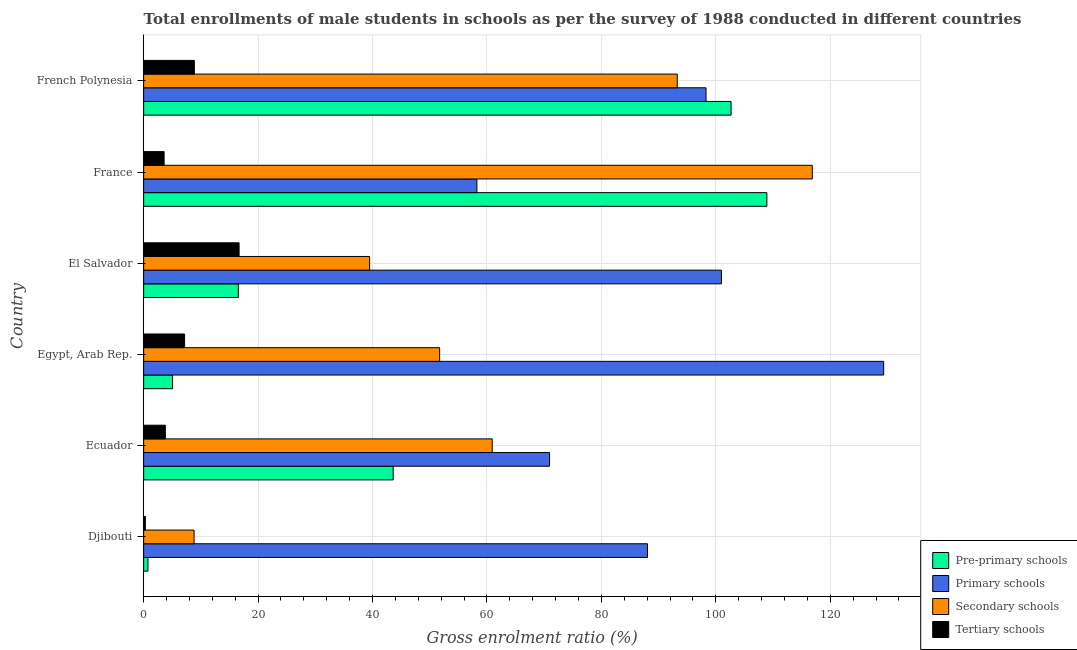Are the number of bars on each tick of the Y-axis equal?
Ensure brevity in your answer.  Yes. How many bars are there on the 3rd tick from the top?
Your answer should be compact. 4. How many bars are there on the 3rd tick from the bottom?
Your answer should be very brief. 4. What is the label of the 6th group of bars from the top?
Provide a short and direct response. Djibouti. What is the gross enrolment ratio(male) in pre-primary schools in Ecuador?
Make the answer very short. 43.61. Across all countries, what is the maximum gross enrolment ratio(male) in pre-primary schools?
Your answer should be compact. 108.92. Across all countries, what is the minimum gross enrolment ratio(male) in primary schools?
Provide a short and direct response. 58.24. In which country was the gross enrolment ratio(male) in tertiary schools minimum?
Provide a succinct answer. Djibouti. What is the total gross enrolment ratio(male) in secondary schools in the graph?
Your answer should be compact. 371.08. What is the difference between the gross enrolment ratio(male) in secondary schools in Djibouti and that in French Polynesia?
Provide a succinct answer. -84.45. What is the difference between the gross enrolment ratio(male) in secondary schools in Ecuador and the gross enrolment ratio(male) in pre-primary schools in Djibouti?
Your answer should be compact. 60.17. What is the average gross enrolment ratio(male) in tertiary schools per country?
Provide a succinct answer. 6.73. What is the difference between the gross enrolment ratio(male) in secondary schools and gross enrolment ratio(male) in primary schools in French Polynesia?
Make the answer very short. -5.03. In how many countries, is the gross enrolment ratio(male) in secondary schools greater than 40 %?
Your answer should be very brief. 4. What is the ratio of the gross enrolment ratio(male) in pre-primary schools in Djibouti to that in France?
Provide a succinct answer. 0.01. Is the gross enrolment ratio(male) in secondary schools in Egypt, Arab Rep. less than that in El Salvador?
Make the answer very short. No. Is the difference between the gross enrolment ratio(male) in pre-primary schools in Djibouti and Egypt, Arab Rep. greater than the difference between the gross enrolment ratio(male) in secondary schools in Djibouti and Egypt, Arab Rep.?
Provide a short and direct response. Yes. What is the difference between the highest and the second highest gross enrolment ratio(male) in primary schools?
Make the answer very short. 28.36. What is the difference between the highest and the lowest gross enrolment ratio(male) in tertiary schools?
Keep it short and to the point. 16.38. In how many countries, is the gross enrolment ratio(male) in primary schools greater than the average gross enrolment ratio(male) in primary schools taken over all countries?
Keep it short and to the point. 3. Is the sum of the gross enrolment ratio(male) in pre-primary schools in France and French Polynesia greater than the maximum gross enrolment ratio(male) in secondary schools across all countries?
Keep it short and to the point. Yes. What does the 3rd bar from the top in France represents?
Offer a very short reply. Primary schools. What does the 1st bar from the bottom in Djibouti represents?
Ensure brevity in your answer.  Pre-primary schools. Are the values on the major ticks of X-axis written in scientific E-notation?
Ensure brevity in your answer.  No. Does the graph contain any zero values?
Keep it short and to the point. No. How many legend labels are there?
Offer a very short reply. 4. How are the legend labels stacked?
Your answer should be compact. Vertical. What is the title of the graph?
Provide a succinct answer. Total enrollments of male students in schools as per the survey of 1988 conducted in different countries. What is the label or title of the X-axis?
Ensure brevity in your answer.  Gross enrolment ratio (%). What is the label or title of the Y-axis?
Your response must be concise. Country. What is the Gross enrolment ratio (%) of Pre-primary schools in Djibouti?
Your answer should be very brief. 0.75. What is the Gross enrolment ratio (%) of Primary schools in Djibouti?
Your answer should be compact. 88.05. What is the Gross enrolment ratio (%) in Secondary schools in Djibouti?
Provide a short and direct response. 8.81. What is the Gross enrolment ratio (%) in Tertiary schools in Djibouti?
Your response must be concise. 0.3. What is the Gross enrolment ratio (%) in Pre-primary schools in Ecuador?
Your response must be concise. 43.61. What is the Gross enrolment ratio (%) of Primary schools in Ecuador?
Your answer should be compact. 70.94. What is the Gross enrolment ratio (%) in Secondary schools in Ecuador?
Provide a succinct answer. 60.92. What is the Gross enrolment ratio (%) of Tertiary schools in Ecuador?
Give a very brief answer. 3.79. What is the Gross enrolment ratio (%) of Pre-primary schools in Egypt, Arab Rep.?
Provide a succinct answer. 5.05. What is the Gross enrolment ratio (%) in Primary schools in Egypt, Arab Rep.?
Your answer should be very brief. 129.34. What is the Gross enrolment ratio (%) of Secondary schools in Egypt, Arab Rep.?
Offer a terse response. 51.73. What is the Gross enrolment ratio (%) in Tertiary schools in Egypt, Arab Rep.?
Provide a succinct answer. 7.16. What is the Gross enrolment ratio (%) of Pre-primary schools in El Salvador?
Keep it short and to the point. 16.54. What is the Gross enrolment ratio (%) of Primary schools in El Salvador?
Offer a very short reply. 100.98. What is the Gross enrolment ratio (%) in Secondary schools in El Salvador?
Provide a succinct answer. 39.5. What is the Gross enrolment ratio (%) in Tertiary schools in El Salvador?
Provide a succinct answer. 16.68. What is the Gross enrolment ratio (%) of Pre-primary schools in France?
Offer a terse response. 108.92. What is the Gross enrolment ratio (%) of Primary schools in France?
Your answer should be compact. 58.24. What is the Gross enrolment ratio (%) of Secondary schools in France?
Make the answer very short. 116.86. What is the Gross enrolment ratio (%) in Tertiary schools in France?
Provide a succinct answer. 3.58. What is the Gross enrolment ratio (%) in Pre-primary schools in French Polynesia?
Give a very brief answer. 102.67. What is the Gross enrolment ratio (%) in Primary schools in French Polynesia?
Ensure brevity in your answer.  98.29. What is the Gross enrolment ratio (%) in Secondary schools in French Polynesia?
Your answer should be compact. 93.26. What is the Gross enrolment ratio (%) of Tertiary schools in French Polynesia?
Ensure brevity in your answer.  8.86. Across all countries, what is the maximum Gross enrolment ratio (%) in Pre-primary schools?
Your response must be concise. 108.92. Across all countries, what is the maximum Gross enrolment ratio (%) of Primary schools?
Your response must be concise. 129.34. Across all countries, what is the maximum Gross enrolment ratio (%) of Secondary schools?
Provide a short and direct response. 116.86. Across all countries, what is the maximum Gross enrolment ratio (%) in Tertiary schools?
Offer a very short reply. 16.68. Across all countries, what is the minimum Gross enrolment ratio (%) of Pre-primary schools?
Ensure brevity in your answer.  0.75. Across all countries, what is the minimum Gross enrolment ratio (%) in Primary schools?
Your answer should be compact. 58.24. Across all countries, what is the minimum Gross enrolment ratio (%) of Secondary schools?
Give a very brief answer. 8.81. Across all countries, what is the minimum Gross enrolment ratio (%) in Tertiary schools?
Your answer should be very brief. 0.3. What is the total Gross enrolment ratio (%) in Pre-primary schools in the graph?
Keep it short and to the point. 277.55. What is the total Gross enrolment ratio (%) of Primary schools in the graph?
Give a very brief answer. 545.85. What is the total Gross enrolment ratio (%) in Secondary schools in the graph?
Ensure brevity in your answer.  371.08. What is the total Gross enrolment ratio (%) in Tertiary schools in the graph?
Ensure brevity in your answer.  40.37. What is the difference between the Gross enrolment ratio (%) in Pre-primary schools in Djibouti and that in Ecuador?
Offer a very short reply. -42.86. What is the difference between the Gross enrolment ratio (%) of Primary schools in Djibouti and that in Ecuador?
Offer a terse response. 17.11. What is the difference between the Gross enrolment ratio (%) in Secondary schools in Djibouti and that in Ecuador?
Your response must be concise. -52.11. What is the difference between the Gross enrolment ratio (%) of Tertiary schools in Djibouti and that in Ecuador?
Offer a very short reply. -3.49. What is the difference between the Gross enrolment ratio (%) of Pre-primary schools in Djibouti and that in Egypt, Arab Rep.?
Offer a very short reply. -4.29. What is the difference between the Gross enrolment ratio (%) of Primary schools in Djibouti and that in Egypt, Arab Rep.?
Give a very brief answer. -41.29. What is the difference between the Gross enrolment ratio (%) of Secondary schools in Djibouti and that in Egypt, Arab Rep.?
Your answer should be very brief. -42.92. What is the difference between the Gross enrolment ratio (%) in Tertiary schools in Djibouti and that in Egypt, Arab Rep.?
Provide a succinct answer. -6.86. What is the difference between the Gross enrolment ratio (%) in Pre-primary schools in Djibouti and that in El Salvador?
Offer a very short reply. -15.79. What is the difference between the Gross enrolment ratio (%) of Primary schools in Djibouti and that in El Salvador?
Ensure brevity in your answer.  -12.93. What is the difference between the Gross enrolment ratio (%) in Secondary schools in Djibouti and that in El Salvador?
Provide a short and direct response. -30.68. What is the difference between the Gross enrolment ratio (%) of Tertiary schools in Djibouti and that in El Salvador?
Offer a very short reply. -16.38. What is the difference between the Gross enrolment ratio (%) of Pre-primary schools in Djibouti and that in France?
Your response must be concise. -108.17. What is the difference between the Gross enrolment ratio (%) of Primary schools in Djibouti and that in France?
Make the answer very short. 29.81. What is the difference between the Gross enrolment ratio (%) of Secondary schools in Djibouti and that in France?
Your answer should be compact. -108.05. What is the difference between the Gross enrolment ratio (%) in Tertiary schools in Djibouti and that in France?
Your answer should be very brief. -3.28. What is the difference between the Gross enrolment ratio (%) in Pre-primary schools in Djibouti and that in French Polynesia?
Provide a short and direct response. -101.92. What is the difference between the Gross enrolment ratio (%) in Primary schools in Djibouti and that in French Polynesia?
Your answer should be very brief. -10.24. What is the difference between the Gross enrolment ratio (%) of Secondary schools in Djibouti and that in French Polynesia?
Give a very brief answer. -84.45. What is the difference between the Gross enrolment ratio (%) of Tertiary schools in Djibouti and that in French Polynesia?
Your response must be concise. -8.56. What is the difference between the Gross enrolment ratio (%) of Pre-primary schools in Ecuador and that in Egypt, Arab Rep.?
Your answer should be very brief. 38.56. What is the difference between the Gross enrolment ratio (%) in Primary schools in Ecuador and that in Egypt, Arab Rep.?
Give a very brief answer. -58.4. What is the difference between the Gross enrolment ratio (%) of Secondary schools in Ecuador and that in Egypt, Arab Rep.?
Offer a very short reply. 9.19. What is the difference between the Gross enrolment ratio (%) in Tertiary schools in Ecuador and that in Egypt, Arab Rep.?
Give a very brief answer. -3.37. What is the difference between the Gross enrolment ratio (%) in Pre-primary schools in Ecuador and that in El Salvador?
Your answer should be compact. 27.07. What is the difference between the Gross enrolment ratio (%) of Primary schools in Ecuador and that in El Salvador?
Give a very brief answer. -30.04. What is the difference between the Gross enrolment ratio (%) of Secondary schools in Ecuador and that in El Salvador?
Make the answer very short. 21.43. What is the difference between the Gross enrolment ratio (%) of Tertiary schools in Ecuador and that in El Salvador?
Provide a short and direct response. -12.89. What is the difference between the Gross enrolment ratio (%) of Pre-primary schools in Ecuador and that in France?
Keep it short and to the point. -65.31. What is the difference between the Gross enrolment ratio (%) in Primary schools in Ecuador and that in France?
Ensure brevity in your answer.  12.7. What is the difference between the Gross enrolment ratio (%) of Secondary schools in Ecuador and that in France?
Give a very brief answer. -55.94. What is the difference between the Gross enrolment ratio (%) of Tertiary schools in Ecuador and that in France?
Your answer should be very brief. 0.21. What is the difference between the Gross enrolment ratio (%) in Pre-primary schools in Ecuador and that in French Polynesia?
Make the answer very short. -59.06. What is the difference between the Gross enrolment ratio (%) in Primary schools in Ecuador and that in French Polynesia?
Provide a succinct answer. -27.35. What is the difference between the Gross enrolment ratio (%) in Secondary schools in Ecuador and that in French Polynesia?
Provide a short and direct response. -32.34. What is the difference between the Gross enrolment ratio (%) of Tertiary schools in Ecuador and that in French Polynesia?
Keep it short and to the point. -5.07. What is the difference between the Gross enrolment ratio (%) of Pre-primary schools in Egypt, Arab Rep. and that in El Salvador?
Offer a terse response. -11.5. What is the difference between the Gross enrolment ratio (%) of Primary schools in Egypt, Arab Rep. and that in El Salvador?
Your response must be concise. 28.36. What is the difference between the Gross enrolment ratio (%) of Secondary schools in Egypt, Arab Rep. and that in El Salvador?
Provide a short and direct response. 12.24. What is the difference between the Gross enrolment ratio (%) in Tertiary schools in Egypt, Arab Rep. and that in El Salvador?
Keep it short and to the point. -9.52. What is the difference between the Gross enrolment ratio (%) of Pre-primary schools in Egypt, Arab Rep. and that in France?
Your response must be concise. -103.87. What is the difference between the Gross enrolment ratio (%) of Primary schools in Egypt, Arab Rep. and that in France?
Your answer should be compact. 71.1. What is the difference between the Gross enrolment ratio (%) of Secondary schools in Egypt, Arab Rep. and that in France?
Provide a short and direct response. -65.13. What is the difference between the Gross enrolment ratio (%) of Tertiary schools in Egypt, Arab Rep. and that in France?
Make the answer very short. 3.58. What is the difference between the Gross enrolment ratio (%) of Pre-primary schools in Egypt, Arab Rep. and that in French Polynesia?
Offer a very short reply. -97.62. What is the difference between the Gross enrolment ratio (%) of Primary schools in Egypt, Arab Rep. and that in French Polynesia?
Provide a short and direct response. 31.05. What is the difference between the Gross enrolment ratio (%) in Secondary schools in Egypt, Arab Rep. and that in French Polynesia?
Your answer should be compact. -41.53. What is the difference between the Gross enrolment ratio (%) in Tertiary schools in Egypt, Arab Rep. and that in French Polynesia?
Your response must be concise. -1.71. What is the difference between the Gross enrolment ratio (%) of Pre-primary schools in El Salvador and that in France?
Your answer should be compact. -92.38. What is the difference between the Gross enrolment ratio (%) of Primary schools in El Salvador and that in France?
Make the answer very short. 42.74. What is the difference between the Gross enrolment ratio (%) in Secondary schools in El Salvador and that in France?
Provide a succinct answer. -77.37. What is the difference between the Gross enrolment ratio (%) of Tertiary schools in El Salvador and that in France?
Keep it short and to the point. 13.1. What is the difference between the Gross enrolment ratio (%) in Pre-primary schools in El Salvador and that in French Polynesia?
Your response must be concise. -86.13. What is the difference between the Gross enrolment ratio (%) in Primary schools in El Salvador and that in French Polynesia?
Give a very brief answer. 2.69. What is the difference between the Gross enrolment ratio (%) of Secondary schools in El Salvador and that in French Polynesia?
Your answer should be very brief. -53.77. What is the difference between the Gross enrolment ratio (%) of Tertiary schools in El Salvador and that in French Polynesia?
Ensure brevity in your answer.  7.82. What is the difference between the Gross enrolment ratio (%) in Pre-primary schools in France and that in French Polynesia?
Your response must be concise. 6.25. What is the difference between the Gross enrolment ratio (%) of Primary schools in France and that in French Polynesia?
Give a very brief answer. -40.05. What is the difference between the Gross enrolment ratio (%) in Secondary schools in France and that in French Polynesia?
Your answer should be compact. 23.6. What is the difference between the Gross enrolment ratio (%) of Tertiary schools in France and that in French Polynesia?
Make the answer very short. -5.28. What is the difference between the Gross enrolment ratio (%) of Pre-primary schools in Djibouti and the Gross enrolment ratio (%) of Primary schools in Ecuador?
Offer a very short reply. -70.19. What is the difference between the Gross enrolment ratio (%) in Pre-primary schools in Djibouti and the Gross enrolment ratio (%) in Secondary schools in Ecuador?
Your answer should be very brief. -60.17. What is the difference between the Gross enrolment ratio (%) of Pre-primary schools in Djibouti and the Gross enrolment ratio (%) of Tertiary schools in Ecuador?
Your answer should be very brief. -3.04. What is the difference between the Gross enrolment ratio (%) of Primary schools in Djibouti and the Gross enrolment ratio (%) of Secondary schools in Ecuador?
Your response must be concise. 27.13. What is the difference between the Gross enrolment ratio (%) of Primary schools in Djibouti and the Gross enrolment ratio (%) of Tertiary schools in Ecuador?
Provide a succinct answer. 84.26. What is the difference between the Gross enrolment ratio (%) of Secondary schools in Djibouti and the Gross enrolment ratio (%) of Tertiary schools in Ecuador?
Your answer should be compact. 5.02. What is the difference between the Gross enrolment ratio (%) of Pre-primary schools in Djibouti and the Gross enrolment ratio (%) of Primary schools in Egypt, Arab Rep.?
Provide a short and direct response. -128.59. What is the difference between the Gross enrolment ratio (%) in Pre-primary schools in Djibouti and the Gross enrolment ratio (%) in Secondary schools in Egypt, Arab Rep.?
Your answer should be very brief. -50.98. What is the difference between the Gross enrolment ratio (%) of Pre-primary schools in Djibouti and the Gross enrolment ratio (%) of Tertiary schools in Egypt, Arab Rep.?
Make the answer very short. -6.4. What is the difference between the Gross enrolment ratio (%) in Primary schools in Djibouti and the Gross enrolment ratio (%) in Secondary schools in Egypt, Arab Rep.?
Give a very brief answer. 36.32. What is the difference between the Gross enrolment ratio (%) of Primary schools in Djibouti and the Gross enrolment ratio (%) of Tertiary schools in Egypt, Arab Rep.?
Your response must be concise. 80.9. What is the difference between the Gross enrolment ratio (%) in Secondary schools in Djibouti and the Gross enrolment ratio (%) in Tertiary schools in Egypt, Arab Rep.?
Your answer should be very brief. 1.66. What is the difference between the Gross enrolment ratio (%) in Pre-primary schools in Djibouti and the Gross enrolment ratio (%) in Primary schools in El Salvador?
Offer a terse response. -100.23. What is the difference between the Gross enrolment ratio (%) of Pre-primary schools in Djibouti and the Gross enrolment ratio (%) of Secondary schools in El Salvador?
Make the answer very short. -38.74. What is the difference between the Gross enrolment ratio (%) of Pre-primary schools in Djibouti and the Gross enrolment ratio (%) of Tertiary schools in El Salvador?
Offer a terse response. -15.93. What is the difference between the Gross enrolment ratio (%) in Primary schools in Djibouti and the Gross enrolment ratio (%) in Secondary schools in El Salvador?
Ensure brevity in your answer.  48.56. What is the difference between the Gross enrolment ratio (%) of Primary schools in Djibouti and the Gross enrolment ratio (%) of Tertiary schools in El Salvador?
Provide a succinct answer. 71.37. What is the difference between the Gross enrolment ratio (%) in Secondary schools in Djibouti and the Gross enrolment ratio (%) in Tertiary schools in El Salvador?
Ensure brevity in your answer.  -7.87. What is the difference between the Gross enrolment ratio (%) of Pre-primary schools in Djibouti and the Gross enrolment ratio (%) of Primary schools in France?
Offer a terse response. -57.49. What is the difference between the Gross enrolment ratio (%) in Pre-primary schools in Djibouti and the Gross enrolment ratio (%) in Secondary schools in France?
Give a very brief answer. -116.11. What is the difference between the Gross enrolment ratio (%) of Pre-primary schools in Djibouti and the Gross enrolment ratio (%) of Tertiary schools in France?
Provide a short and direct response. -2.82. What is the difference between the Gross enrolment ratio (%) in Primary schools in Djibouti and the Gross enrolment ratio (%) in Secondary schools in France?
Ensure brevity in your answer.  -28.81. What is the difference between the Gross enrolment ratio (%) in Primary schools in Djibouti and the Gross enrolment ratio (%) in Tertiary schools in France?
Your answer should be very brief. 84.48. What is the difference between the Gross enrolment ratio (%) of Secondary schools in Djibouti and the Gross enrolment ratio (%) of Tertiary schools in France?
Your response must be concise. 5.24. What is the difference between the Gross enrolment ratio (%) of Pre-primary schools in Djibouti and the Gross enrolment ratio (%) of Primary schools in French Polynesia?
Offer a very short reply. -97.53. What is the difference between the Gross enrolment ratio (%) in Pre-primary schools in Djibouti and the Gross enrolment ratio (%) in Secondary schools in French Polynesia?
Make the answer very short. -92.51. What is the difference between the Gross enrolment ratio (%) of Pre-primary schools in Djibouti and the Gross enrolment ratio (%) of Tertiary schools in French Polynesia?
Provide a succinct answer. -8.11. What is the difference between the Gross enrolment ratio (%) in Primary schools in Djibouti and the Gross enrolment ratio (%) in Secondary schools in French Polynesia?
Your response must be concise. -5.21. What is the difference between the Gross enrolment ratio (%) of Primary schools in Djibouti and the Gross enrolment ratio (%) of Tertiary schools in French Polynesia?
Provide a succinct answer. 79.19. What is the difference between the Gross enrolment ratio (%) of Secondary schools in Djibouti and the Gross enrolment ratio (%) of Tertiary schools in French Polynesia?
Make the answer very short. -0.05. What is the difference between the Gross enrolment ratio (%) in Pre-primary schools in Ecuador and the Gross enrolment ratio (%) in Primary schools in Egypt, Arab Rep.?
Make the answer very short. -85.73. What is the difference between the Gross enrolment ratio (%) in Pre-primary schools in Ecuador and the Gross enrolment ratio (%) in Secondary schools in Egypt, Arab Rep.?
Your response must be concise. -8.12. What is the difference between the Gross enrolment ratio (%) of Pre-primary schools in Ecuador and the Gross enrolment ratio (%) of Tertiary schools in Egypt, Arab Rep.?
Keep it short and to the point. 36.46. What is the difference between the Gross enrolment ratio (%) of Primary schools in Ecuador and the Gross enrolment ratio (%) of Secondary schools in Egypt, Arab Rep.?
Your answer should be compact. 19.21. What is the difference between the Gross enrolment ratio (%) of Primary schools in Ecuador and the Gross enrolment ratio (%) of Tertiary schools in Egypt, Arab Rep.?
Keep it short and to the point. 63.79. What is the difference between the Gross enrolment ratio (%) of Secondary schools in Ecuador and the Gross enrolment ratio (%) of Tertiary schools in Egypt, Arab Rep.?
Make the answer very short. 53.76. What is the difference between the Gross enrolment ratio (%) of Pre-primary schools in Ecuador and the Gross enrolment ratio (%) of Primary schools in El Salvador?
Offer a very short reply. -57.37. What is the difference between the Gross enrolment ratio (%) of Pre-primary schools in Ecuador and the Gross enrolment ratio (%) of Secondary schools in El Salvador?
Make the answer very short. 4.12. What is the difference between the Gross enrolment ratio (%) in Pre-primary schools in Ecuador and the Gross enrolment ratio (%) in Tertiary schools in El Salvador?
Keep it short and to the point. 26.93. What is the difference between the Gross enrolment ratio (%) in Primary schools in Ecuador and the Gross enrolment ratio (%) in Secondary schools in El Salvador?
Provide a short and direct response. 31.45. What is the difference between the Gross enrolment ratio (%) in Primary schools in Ecuador and the Gross enrolment ratio (%) in Tertiary schools in El Salvador?
Make the answer very short. 54.26. What is the difference between the Gross enrolment ratio (%) of Secondary schools in Ecuador and the Gross enrolment ratio (%) of Tertiary schools in El Salvador?
Your answer should be very brief. 44.24. What is the difference between the Gross enrolment ratio (%) of Pre-primary schools in Ecuador and the Gross enrolment ratio (%) of Primary schools in France?
Offer a terse response. -14.63. What is the difference between the Gross enrolment ratio (%) in Pre-primary schools in Ecuador and the Gross enrolment ratio (%) in Secondary schools in France?
Provide a succinct answer. -73.25. What is the difference between the Gross enrolment ratio (%) of Pre-primary schools in Ecuador and the Gross enrolment ratio (%) of Tertiary schools in France?
Keep it short and to the point. 40.03. What is the difference between the Gross enrolment ratio (%) in Primary schools in Ecuador and the Gross enrolment ratio (%) in Secondary schools in France?
Your response must be concise. -45.92. What is the difference between the Gross enrolment ratio (%) of Primary schools in Ecuador and the Gross enrolment ratio (%) of Tertiary schools in France?
Provide a succinct answer. 67.37. What is the difference between the Gross enrolment ratio (%) of Secondary schools in Ecuador and the Gross enrolment ratio (%) of Tertiary schools in France?
Provide a short and direct response. 57.34. What is the difference between the Gross enrolment ratio (%) in Pre-primary schools in Ecuador and the Gross enrolment ratio (%) in Primary schools in French Polynesia?
Provide a short and direct response. -54.68. What is the difference between the Gross enrolment ratio (%) of Pre-primary schools in Ecuador and the Gross enrolment ratio (%) of Secondary schools in French Polynesia?
Give a very brief answer. -49.65. What is the difference between the Gross enrolment ratio (%) in Pre-primary schools in Ecuador and the Gross enrolment ratio (%) in Tertiary schools in French Polynesia?
Your response must be concise. 34.75. What is the difference between the Gross enrolment ratio (%) in Primary schools in Ecuador and the Gross enrolment ratio (%) in Secondary schools in French Polynesia?
Give a very brief answer. -22.32. What is the difference between the Gross enrolment ratio (%) in Primary schools in Ecuador and the Gross enrolment ratio (%) in Tertiary schools in French Polynesia?
Your answer should be very brief. 62.08. What is the difference between the Gross enrolment ratio (%) of Secondary schools in Ecuador and the Gross enrolment ratio (%) of Tertiary schools in French Polynesia?
Provide a short and direct response. 52.06. What is the difference between the Gross enrolment ratio (%) in Pre-primary schools in Egypt, Arab Rep. and the Gross enrolment ratio (%) in Primary schools in El Salvador?
Provide a succinct answer. -95.93. What is the difference between the Gross enrolment ratio (%) of Pre-primary schools in Egypt, Arab Rep. and the Gross enrolment ratio (%) of Secondary schools in El Salvador?
Make the answer very short. -34.45. What is the difference between the Gross enrolment ratio (%) of Pre-primary schools in Egypt, Arab Rep. and the Gross enrolment ratio (%) of Tertiary schools in El Salvador?
Make the answer very short. -11.63. What is the difference between the Gross enrolment ratio (%) in Primary schools in Egypt, Arab Rep. and the Gross enrolment ratio (%) in Secondary schools in El Salvador?
Offer a very short reply. 89.84. What is the difference between the Gross enrolment ratio (%) of Primary schools in Egypt, Arab Rep. and the Gross enrolment ratio (%) of Tertiary schools in El Salvador?
Offer a very short reply. 112.66. What is the difference between the Gross enrolment ratio (%) of Secondary schools in Egypt, Arab Rep. and the Gross enrolment ratio (%) of Tertiary schools in El Salvador?
Give a very brief answer. 35.05. What is the difference between the Gross enrolment ratio (%) of Pre-primary schools in Egypt, Arab Rep. and the Gross enrolment ratio (%) of Primary schools in France?
Make the answer very short. -53.19. What is the difference between the Gross enrolment ratio (%) in Pre-primary schools in Egypt, Arab Rep. and the Gross enrolment ratio (%) in Secondary schools in France?
Offer a terse response. -111.81. What is the difference between the Gross enrolment ratio (%) of Pre-primary schools in Egypt, Arab Rep. and the Gross enrolment ratio (%) of Tertiary schools in France?
Your response must be concise. 1.47. What is the difference between the Gross enrolment ratio (%) of Primary schools in Egypt, Arab Rep. and the Gross enrolment ratio (%) of Secondary schools in France?
Ensure brevity in your answer.  12.48. What is the difference between the Gross enrolment ratio (%) of Primary schools in Egypt, Arab Rep. and the Gross enrolment ratio (%) of Tertiary schools in France?
Give a very brief answer. 125.76. What is the difference between the Gross enrolment ratio (%) in Secondary schools in Egypt, Arab Rep. and the Gross enrolment ratio (%) in Tertiary schools in France?
Offer a terse response. 48.15. What is the difference between the Gross enrolment ratio (%) of Pre-primary schools in Egypt, Arab Rep. and the Gross enrolment ratio (%) of Primary schools in French Polynesia?
Your response must be concise. -93.24. What is the difference between the Gross enrolment ratio (%) of Pre-primary schools in Egypt, Arab Rep. and the Gross enrolment ratio (%) of Secondary schools in French Polynesia?
Ensure brevity in your answer.  -88.21. What is the difference between the Gross enrolment ratio (%) in Pre-primary schools in Egypt, Arab Rep. and the Gross enrolment ratio (%) in Tertiary schools in French Polynesia?
Your answer should be very brief. -3.81. What is the difference between the Gross enrolment ratio (%) of Primary schools in Egypt, Arab Rep. and the Gross enrolment ratio (%) of Secondary schools in French Polynesia?
Your response must be concise. 36.08. What is the difference between the Gross enrolment ratio (%) in Primary schools in Egypt, Arab Rep. and the Gross enrolment ratio (%) in Tertiary schools in French Polynesia?
Keep it short and to the point. 120.48. What is the difference between the Gross enrolment ratio (%) in Secondary schools in Egypt, Arab Rep. and the Gross enrolment ratio (%) in Tertiary schools in French Polynesia?
Provide a short and direct response. 42.87. What is the difference between the Gross enrolment ratio (%) in Pre-primary schools in El Salvador and the Gross enrolment ratio (%) in Primary schools in France?
Offer a very short reply. -41.7. What is the difference between the Gross enrolment ratio (%) of Pre-primary schools in El Salvador and the Gross enrolment ratio (%) of Secondary schools in France?
Provide a succinct answer. -100.32. What is the difference between the Gross enrolment ratio (%) in Pre-primary schools in El Salvador and the Gross enrolment ratio (%) in Tertiary schools in France?
Provide a succinct answer. 12.97. What is the difference between the Gross enrolment ratio (%) of Primary schools in El Salvador and the Gross enrolment ratio (%) of Secondary schools in France?
Make the answer very short. -15.88. What is the difference between the Gross enrolment ratio (%) of Primary schools in El Salvador and the Gross enrolment ratio (%) of Tertiary schools in France?
Make the answer very short. 97.4. What is the difference between the Gross enrolment ratio (%) in Secondary schools in El Salvador and the Gross enrolment ratio (%) in Tertiary schools in France?
Your answer should be compact. 35.92. What is the difference between the Gross enrolment ratio (%) in Pre-primary schools in El Salvador and the Gross enrolment ratio (%) in Primary schools in French Polynesia?
Your answer should be compact. -81.74. What is the difference between the Gross enrolment ratio (%) in Pre-primary schools in El Salvador and the Gross enrolment ratio (%) in Secondary schools in French Polynesia?
Ensure brevity in your answer.  -76.72. What is the difference between the Gross enrolment ratio (%) in Pre-primary schools in El Salvador and the Gross enrolment ratio (%) in Tertiary schools in French Polynesia?
Provide a succinct answer. 7.68. What is the difference between the Gross enrolment ratio (%) in Primary schools in El Salvador and the Gross enrolment ratio (%) in Secondary schools in French Polynesia?
Your answer should be compact. 7.72. What is the difference between the Gross enrolment ratio (%) in Primary schools in El Salvador and the Gross enrolment ratio (%) in Tertiary schools in French Polynesia?
Provide a succinct answer. 92.12. What is the difference between the Gross enrolment ratio (%) in Secondary schools in El Salvador and the Gross enrolment ratio (%) in Tertiary schools in French Polynesia?
Provide a succinct answer. 30.63. What is the difference between the Gross enrolment ratio (%) in Pre-primary schools in France and the Gross enrolment ratio (%) in Primary schools in French Polynesia?
Give a very brief answer. 10.63. What is the difference between the Gross enrolment ratio (%) of Pre-primary schools in France and the Gross enrolment ratio (%) of Secondary schools in French Polynesia?
Offer a very short reply. 15.66. What is the difference between the Gross enrolment ratio (%) of Pre-primary schools in France and the Gross enrolment ratio (%) of Tertiary schools in French Polynesia?
Ensure brevity in your answer.  100.06. What is the difference between the Gross enrolment ratio (%) of Primary schools in France and the Gross enrolment ratio (%) of Secondary schools in French Polynesia?
Give a very brief answer. -35.02. What is the difference between the Gross enrolment ratio (%) of Primary schools in France and the Gross enrolment ratio (%) of Tertiary schools in French Polynesia?
Provide a succinct answer. 49.38. What is the difference between the Gross enrolment ratio (%) in Secondary schools in France and the Gross enrolment ratio (%) in Tertiary schools in French Polynesia?
Offer a very short reply. 108. What is the average Gross enrolment ratio (%) of Pre-primary schools per country?
Keep it short and to the point. 46.26. What is the average Gross enrolment ratio (%) of Primary schools per country?
Your response must be concise. 90.97. What is the average Gross enrolment ratio (%) of Secondary schools per country?
Ensure brevity in your answer.  61.85. What is the average Gross enrolment ratio (%) in Tertiary schools per country?
Keep it short and to the point. 6.73. What is the difference between the Gross enrolment ratio (%) in Pre-primary schools and Gross enrolment ratio (%) in Primary schools in Djibouti?
Give a very brief answer. -87.3. What is the difference between the Gross enrolment ratio (%) in Pre-primary schools and Gross enrolment ratio (%) in Secondary schools in Djibouti?
Keep it short and to the point. -8.06. What is the difference between the Gross enrolment ratio (%) of Pre-primary schools and Gross enrolment ratio (%) of Tertiary schools in Djibouti?
Provide a short and direct response. 0.45. What is the difference between the Gross enrolment ratio (%) of Primary schools and Gross enrolment ratio (%) of Secondary schools in Djibouti?
Your answer should be very brief. 79.24. What is the difference between the Gross enrolment ratio (%) of Primary schools and Gross enrolment ratio (%) of Tertiary schools in Djibouti?
Offer a terse response. 87.75. What is the difference between the Gross enrolment ratio (%) in Secondary schools and Gross enrolment ratio (%) in Tertiary schools in Djibouti?
Give a very brief answer. 8.51. What is the difference between the Gross enrolment ratio (%) of Pre-primary schools and Gross enrolment ratio (%) of Primary schools in Ecuador?
Your response must be concise. -27.33. What is the difference between the Gross enrolment ratio (%) in Pre-primary schools and Gross enrolment ratio (%) in Secondary schools in Ecuador?
Give a very brief answer. -17.31. What is the difference between the Gross enrolment ratio (%) in Pre-primary schools and Gross enrolment ratio (%) in Tertiary schools in Ecuador?
Keep it short and to the point. 39.82. What is the difference between the Gross enrolment ratio (%) of Primary schools and Gross enrolment ratio (%) of Secondary schools in Ecuador?
Provide a short and direct response. 10.02. What is the difference between the Gross enrolment ratio (%) of Primary schools and Gross enrolment ratio (%) of Tertiary schools in Ecuador?
Your answer should be compact. 67.15. What is the difference between the Gross enrolment ratio (%) of Secondary schools and Gross enrolment ratio (%) of Tertiary schools in Ecuador?
Give a very brief answer. 57.13. What is the difference between the Gross enrolment ratio (%) of Pre-primary schools and Gross enrolment ratio (%) of Primary schools in Egypt, Arab Rep.?
Your answer should be compact. -124.29. What is the difference between the Gross enrolment ratio (%) of Pre-primary schools and Gross enrolment ratio (%) of Secondary schools in Egypt, Arab Rep.?
Make the answer very short. -46.68. What is the difference between the Gross enrolment ratio (%) in Pre-primary schools and Gross enrolment ratio (%) in Tertiary schools in Egypt, Arab Rep.?
Your answer should be very brief. -2.11. What is the difference between the Gross enrolment ratio (%) in Primary schools and Gross enrolment ratio (%) in Secondary schools in Egypt, Arab Rep.?
Offer a terse response. 77.61. What is the difference between the Gross enrolment ratio (%) in Primary schools and Gross enrolment ratio (%) in Tertiary schools in Egypt, Arab Rep.?
Give a very brief answer. 122.18. What is the difference between the Gross enrolment ratio (%) in Secondary schools and Gross enrolment ratio (%) in Tertiary schools in Egypt, Arab Rep.?
Provide a succinct answer. 44.57. What is the difference between the Gross enrolment ratio (%) of Pre-primary schools and Gross enrolment ratio (%) of Primary schools in El Salvador?
Give a very brief answer. -84.44. What is the difference between the Gross enrolment ratio (%) of Pre-primary schools and Gross enrolment ratio (%) of Secondary schools in El Salvador?
Your response must be concise. -22.95. What is the difference between the Gross enrolment ratio (%) in Pre-primary schools and Gross enrolment ratio (%) in Tertiary schools in El Salvador?
Your answer should be very brief. -0.14. What is the difference between the Gross enrolment ratio (%) of Primary schools and Gross enrolment ratio (%) of Secondary schools in El Salvador?
Give a very brief answer. 61.49. What is the difference between the Gross enrolment ratio (%) in Primary schools and Gross enrolment ratio (%) in Tertiary schools in El Salvador?
Offer a very short reply. 84.3. What is the difference between the Gross enrolment ratio (%) in Secondary schools and Gross enrolment ratio (%) in Tertiary schools in El Salvador?
Offer a very short reply. 22.81. What is the difference between the Gross enrolment ratio (%) in Pre-primary schools and Gross enrolment ratio (%) in Primary schools in France?
Give a very brief answer. 50.68. What is the difference between the Gross enrolment ratio (%) of Pre-primary schools and Gross enrolment ratio (%) of Secondary schools in France?
Your response must be concise. -7.94. What is the difference between the Gross enrolment ratio (%) of Pre-primary schools and Gross enrolment ratio (%) of Tertiary schools in France?
Provide a succinct answer. 105.35. What is the difference between the Gross enrolment ratio (%) of Primary schools and Gross enrolment ratio (%) of Secondary schools in France?
Your answer should be very brief. -58.62. What is the difference between the Gross enrolment ratio (%) of Primary schools and Gross enrolment ratio (%) of Tertiary schools in France?
Your answer should be very brief. 54.67. What is the difference between the Gross enrolment ratio (%) in Secondary schools and Gross enrolment ratio (%) in Tertiary schools in France?
Provide a succinct answer. 113.28. What is the difference between the Gross enrolment ratio (%) in Pre-primary schools and Gross enrolment ratio (%) in Primary schools in French Polynesia?
Keep it short and to the point. 4.38. What is the difference between the Gross enrolment ratio (%) in Pre-primary schools and Gross enrolment ratio (%) in Secondary schools in French Polynesia?
Your answer should be very brief. 9.41. What is the difference between the Gross enrolment ratio (%) in Pre-primary schools and Gross enrolment ratio (%) in Tertiary schools in French Polynesia?
Your response must be concise. 93.81. What is the difference between the Gross enrolment ratio (%) in Primary schools and Gross enrolment ratio (%) in Secondary schools in French Polynesia?
Your answer should be compact. 5.03. What is the difference between the Gross enrolment ratio (%) of Primary schools and Gross enrolment ratio (%) of Tertiary schools in French Polynesia?
Ensure brevity in your answer.  89.43. What is the difference between the Gross enrolment ratio (%) in Secondary schools and Gross enrolment ratio (%) in Tertiary schools in French Polynesia?
Make the answer very short. 84.4. What is the ratio of the Gross enrolment ratio (%) in Pre-primary schools in Djibouti to that in Ecuador?
Offer a very short reply. 0.02. What is the ratio of the Gross enrolment ratio (%) of Primary schools in Djibouti to that in Ecuador?
Your response must be concise. 1.24. What is the ratio of the Gross enrolment ratio (%) of Secondary schools in Djibouti to that in Ecuador?
Make the answer very short. 0.14. What is the ratio of the Gross enrolment ratio (%) in Tertiary schools in Djibouti to that in Ecuador?
Your answer should be very brief. 0.08. What is the ratio of the Gross enrolment ratio (%) in Pre-primary schools in Djibouti to that in Egypt, Arab Rep.?
Provide a short and direct response. 0.15. What is the ratio of the Gross enrolment ratio (%) in Primary schools in Djibouti to that in Egypt, Arab Rep.?
Your answer should be compact. 0.68. What is the ratio of the Gross enrolment ratio (%) of Secondary schools in Djibouti to that in Egypt, Arab Rep.?
Give a very brief answer. 0.17. What is the ratio of the Gross enrolment ratio (%) of Tertiary schools in Djibouti to that in Egypt, Arab Rep.?
Offer a very short reply. 0.04. What is the ratio of the Gross enrolment ratio (%) in Pre-primary schools in Djibouti to that in El Salvador?
Offer a terse response. 0.05. What is the ratio of the Gross enrolment ratio (%) in Primary schools in Djibouti to that in El Salvador?
Provide a short and direct response. 0.87. What is the ratio of the Gross enrolment ratio (%) in Secondary schools in Djibouti to that in El Salvador?
Your answer should be compact. 0.22. What is the ratio of the Gross enrolment ratio (%) in Tertiary schools in Djibouti to that in El Salvador?
Your response must be concise. 0.02. What is the ratio of the Gross enrolment ratio (%) in Pre-primary schools in Djibouti to that in France?
Your answer should be compact. 0.01. What is the ratio of the Gross enrolment ratio (%) in Primary schools in Djibouti to that in France?
Your answer should be compact. 1.51. What is the ratio of the Gross enrolment ratio (%) of Secondary schools in Djibouti to that in France?
Ensure brevity in your answer.  0.08. What is the ratio of the Gross enrolment ratio (%) in Tertiary schools in Djibouti to that in France?
Your answer should be compact. 0.08. What is the ratio of the Gross enrolment ratio (%) in Pre-primary schools in Djibouti to that in French Polynesia?
Make the answer very short. 0.01. What is the ratio of the Gross enrolment ratio (%) of Primary schools in Djibouti to that in French Polynesia?
Keep it short and to the point. 0.9. What is the ratio of the Gross enrolment ratio (%) of Secondary schools in Djibouti to that in French Polynesia?
Your response must be concise. 0.09. What is the ratio of the Gross enrolment ratio (%) in Tertiary schools in Djibouti to that in French Polynesia?
Ensure brevity in your answer.  0.03. What is the ratio of the Gross enrolment ratio (%) in Pre-primary schools in Ecuador to that in Egypt, Arab Rep.?
Make the answer very short. 8.64. What is the ratio of the Gross enrolment ratio (%) in Primary schools in Ecuador to that in Egypt, Arab Rep.?
Make the answer very short. 0.55. What is the ratio of the Gross enrolment ratio (%) of Secondary schools in Ecuador to that in Egypt, Arab Rep.?
Keep it short and to the point. 1.18. What is the ratio of the Gross enrolment ratio (%) of Tertiary schools in Ecuador to that in Egypt, Arab Rep.?
Your answer should be very brief. 0.53. What is the ratio of the Gross enrolment ratio (%) in Pre-primary schools in Ecuador to that in El Salvador?
Provide a succinct answer. 2.64. What is the ratio of the Gross enrolment ratio (%) of Primary schools in Ecuador to that in El Salvador?
Your answer should be compact. 0.7. What is the ratio of the Gross enrolment ratio (%) of Secondary schools in Ecuador to that in El Salvador?
Offer a very short reply. 1.54. What is the ratio of the Gross enrolment ratio (%) of Tertiary schools in Ecuador to that in El Salvador?
Keep it short and to the point. 0.23. What is the ratio of the Gross enrolment ratio (%) of Pre-primary schools in Ecuador to that in France?
Provide a succinct answer. 0.4. What is the ratio of the Gross enrolment ratio (%) in Primary schools in Ecuador to that in France?
Your answer should be compact. 1.22. What is the ratio of the Gross enrolment ratio (%) in Secondary schools in Ecuador to that in France?
Provide a short and direct response. 0.52. What is the ratio of the Gross enrolment ratio (%) of Tertiary schools in Ecuador to that in France?
Make the answer very short. 1.06. What is the ratio of the Gross enrolment ratio (%) of Pre-primary schools in Ecuador to that in French Polynesia?
Provide a short and direct response. 0.42. What is the ratio of the Gross enrolment ratio (%) in Primary schools in Ecuador to that in French Polynesia?
Your answer should be compact. 0.72. What is the ratio of the Gross enrolment ratio (%) of Secondary schools in Ecuador to that in French Polynesia?
Your answer should be compact. 0.65. What is the ratio of the Gross enrolment ratio (%) in Tertiary schools in Ecuador to that in French Polynesia?
Your answer should be compact. 0.43. What is the ratio of the Gross enrolment ratio (%) of Pre-primary schools in Egypt, Arab Rep. to that in El Salvador?
Offer a terse response. 0.31. What is the ratio of the Gross enrolment ratio (%) in Primary schools in Egypt, Arab Rep. to that in El Salvador?
Make the answer very short. 1.28. What is the ratio of the Gross enrolment ratio (%) of Secondary schools in Egypt, Arab Rep. to that in El Salvador?
Give a very brief answer. 1.31. What is the ratio of the Gross enrolment ratio (%) in Tertiary schools in Egypt, Arab Rep. to that in El Salvador?
Provide a short and direct response. 0.43. What is the ratio of the Gross enrolment ratio (%) of Pre-primary schools in Egypt, Arab Rep. to that in France?
Provide a short and direct response. 0.05. What is the ratio of the Gross enrolment ratio (%) of Primary schools in Egypt, Arab Rep. to that in France?
Offer a very short reply. 2.22. What is the ratio of the Gross enrolment ratio (%) of Secondary schools in Egypt, Arab Rep. to that in France?
Give a very brief answer. 0.44. What is the ratio of the Gross enrolment ratio (%) of Tertiary schools in Egypt, Arab Rep. to that in France?
Provide a short and direct response. 2. What is the ratio of the Gross enrolment ratio (%) of Pre-primary schools in Egypt, Arab Rep. to that in French Polynesia?
Offer a very short reply. 0.05. What is the ratio of the Gross enrolment ratio (%) in Primary schools in Egypt, Arab Rep. to that in French Polynesia?
Provide a succinct answer. 1.32. What is the ratio of the Gross enrolment ratio (%) of Secondary schools in Egypt, Arab Rep. to that in French Polynesia?
Offer a very short reply. 0.55. What is the ratio of the Gross enrolment ratio (%) in Tertiary schools in Egypt, Arab Rep. to that in French Polynesia?
Provide a short and direct response. 0.81. What is the ratio of the Gross enrolment ratio (%) in Pre-primary schools in El Salvador to that in France?
Offer a very short reply. 0.15. What is the ratio of the Gross enrolment ratio (%) in Primary schools in El Salvador to that in France?
Your answer should be compact. 1.73. What is the ratio of the Gross enrolment ratio (%) in Secondary schools in El Salvador to that in France?
Ensure brevity in your answer.  0.34. What is the ratio of the Gross enrolment ratio (%) in Tertiary schools in El Salvador to that in France?
Your response must be concise. 4.66. What is the ratio of the Gross enrolment ratio (%) in Pre-primary schools in El Salvador to that in French Polynesia?
Make the answer very short. 0.16. What is the ratio of the Gross enrolment ratio (%) in Primary schools in El Salvador to that in French Polynesia?
Keep it short and to the point. 1.03. What is the ratio of the Gross enrolment ratio (%) of Secondary schools in El Salvador to that in French Polynesia?
Your answer should be compact. 0.42. What is the ratio of the Gross enrolment ratio (%) of Tertiary schools in El Salvador to that in French Polynesia?
Give a very brief answer. 1.88. What is the ratio of the Gross enrolment ratio (%) in Pre-primary schools in France to that in French Polynesia?
Provide a short and direct response. 1.06. What is the ratio of the Gross enrolment ratio (%) in Primary schools in France to that in French Polynesia?
Provide a short and direct response. 0.59. What is the ratio of the Gross enrolment ratio (%) of Secondary schools in France to that in French Polynesia?
Your answer should be compact. 1.25. What is the ratio of the Gross enrolment ratio (%) of Tertiary schools in France to that in French Polynesia?
Ensure brevity in your answer.  0.4. What is the difference between the highest and the second highest Gross enrolment ratio (%) in Pre-primary schools?
Make the answer very short. 6.25. What is the difference between the highest and the second highest Gross enrolment ratio (%) in Primary schools?
Your response must be concise. 28.36. What is the difference between the highest and the second highest Gross enrolment ratio (%) in Secondary schools?
Your answer should be very brief. 23.6. What is the difference between the highest and the second highest Gross enrolment ratio (%) of Tertiary schools?
Make the answer very short. 7.82. What is the difference between the highest and the lowest Gross enrolment ratio (%) of Pre-primary schools?
Provide a succinct answer. 108.17. What is the difference between the highest and the lowest Gross enrolment ratio (%) of Primary schools?
Provide a succinct answer. 71.1. What is the difference between the highest and the lowest Gross enrolment ratio (%) in Secondary schools?
Give a very brief answer. 108.05. What is the difference between the highest and the lowest Gross enrolment ratio (%) of Tertiary schools?
Ensure brevity in your answer.  16.38. 